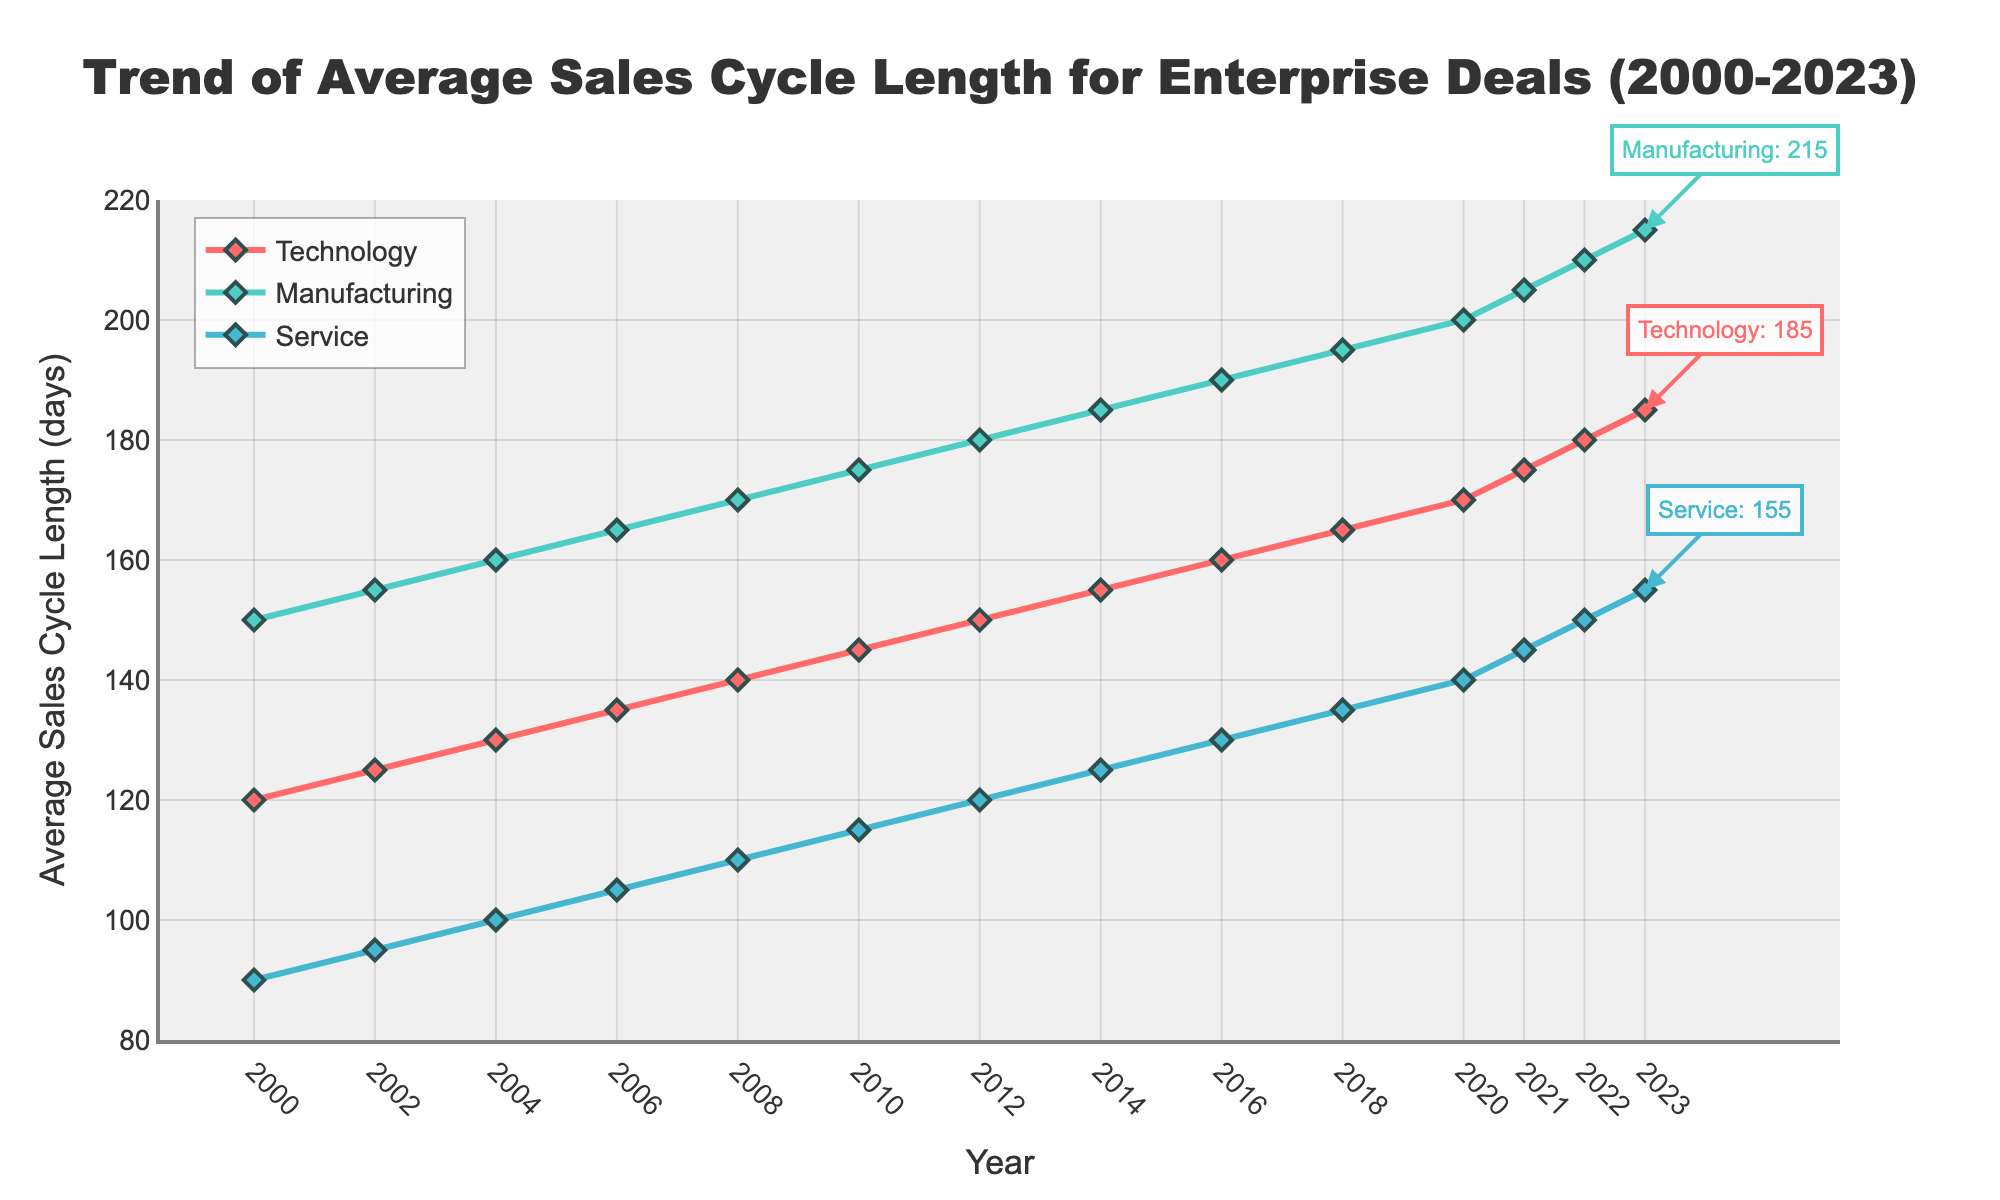What's the trend of average sales cycle length in the Technology sector from 2000 to 2023? The plot shows a consistent upward trend for the Technology sector. Starting from 120 days in 2000, the average sales cycle length grows steadily over the years to reach 185 days in 2023.
Answer: Upward How does the average sales cycle length in the Manufacturing sector in 2010 compare to that in the Service sector in the same year? In 2010, the Manufacturing sector's average sales cycle length was 175 days, while the Service sector's average sales cycle length was 115 days. The length for Manufacturing was 60 days longer than that for Service in 2010.
Answer: 60 days longer What is the difference in the average sales cycle length for the Technology sector between the years 2000 and 2023? In 2000, the Technology sector had an average sales cycle length of 120 days, which increased to 185 days in 2023. The difference is 185 - 120 = 65 days.
Answer: 65 days Between which two consecutive years was the largest increase in average sales cycle length observed for the Manufacturing sector? Observing the graph, the Manufacturing sector shows a gradual increase. However, between 2020 (200 days) and 2021 (205 days), there is an increase of 5 days, which is the largest consecutive increase depicted.
Answer: 2020 and 2021 What's the average of the average sales cycle lengths of the Service sector from 2000 to 2023? The lengths are [90, 95, 100, 105, 110, 115, 120, 125, 130, 135, 140, 145, 150, 155]. Summing these up gives 1615. There are 14 data points, so the average is 1615 / 14 = 115.36.
Answer: 115.36 Which sector had the shortest average sales cycle length in 2008, and what was its length? By observing the graph at the year 2008 point, the Service sector had the shortest average sales cycle length with 110 days.
Answer: Service; 110 days What color represents the Manufacturing sector in the figure? The color representing the Manufacturing sector is identifiable in the figure as green.
Answer: Green How does the average sales cycle length in the Service sector in 2023 compare to that in the Technology sector in 2000? In 2023, the average sales cycle length for the Service sector was 155 days. Comparing this to the Technology sector in 2000, which was 120 days, the Service sector's length in 2023 is longer by 35 days.
Answer: 35 days longer What sector shows the highest value for average sales cycle length in 2023, and what is the value? In 2023, the graph shows that the Manufacturing sector has the highest value for average sales cycle length, which is 215 days.
Answer: Manufacturing; 215 days 